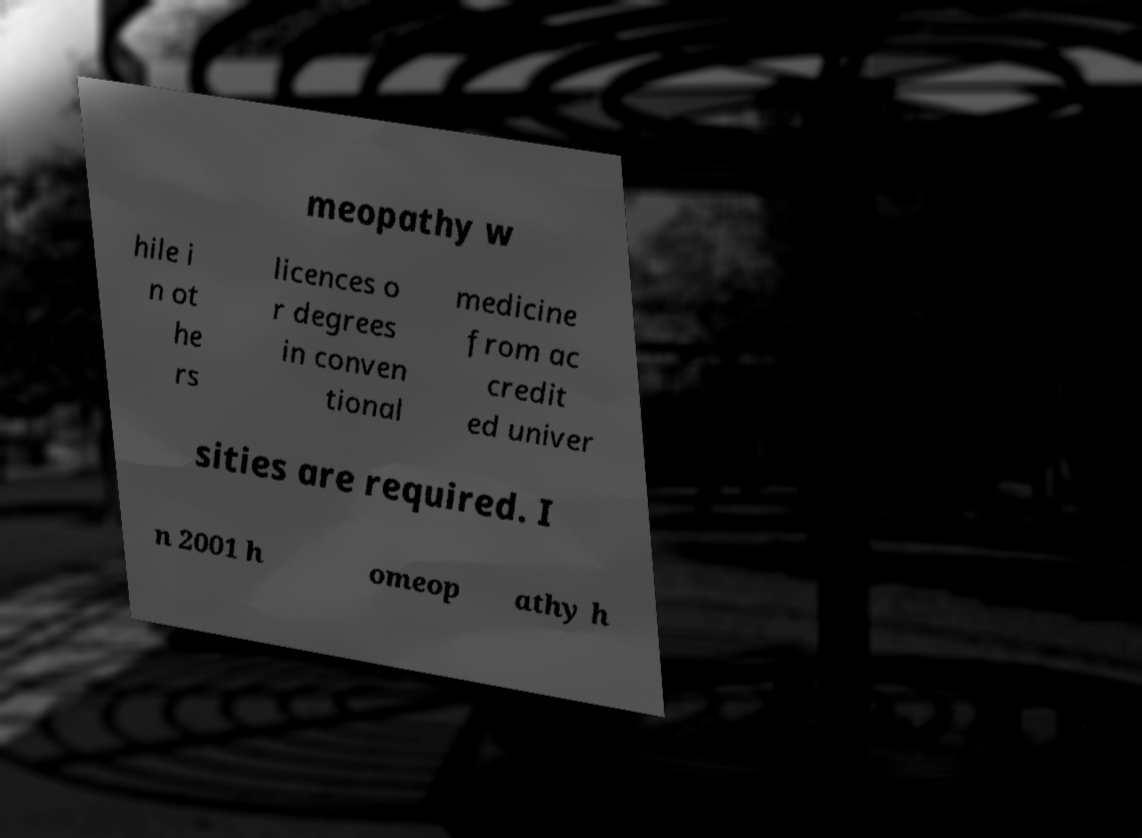What messages or text are displayed in this image? I need them in a readable, typed format. meopathy w hile i n ot he rs licences o r degrees in conven tional medicine from ac credit ed univer sities are required. I n 2001 h omeop athy h 